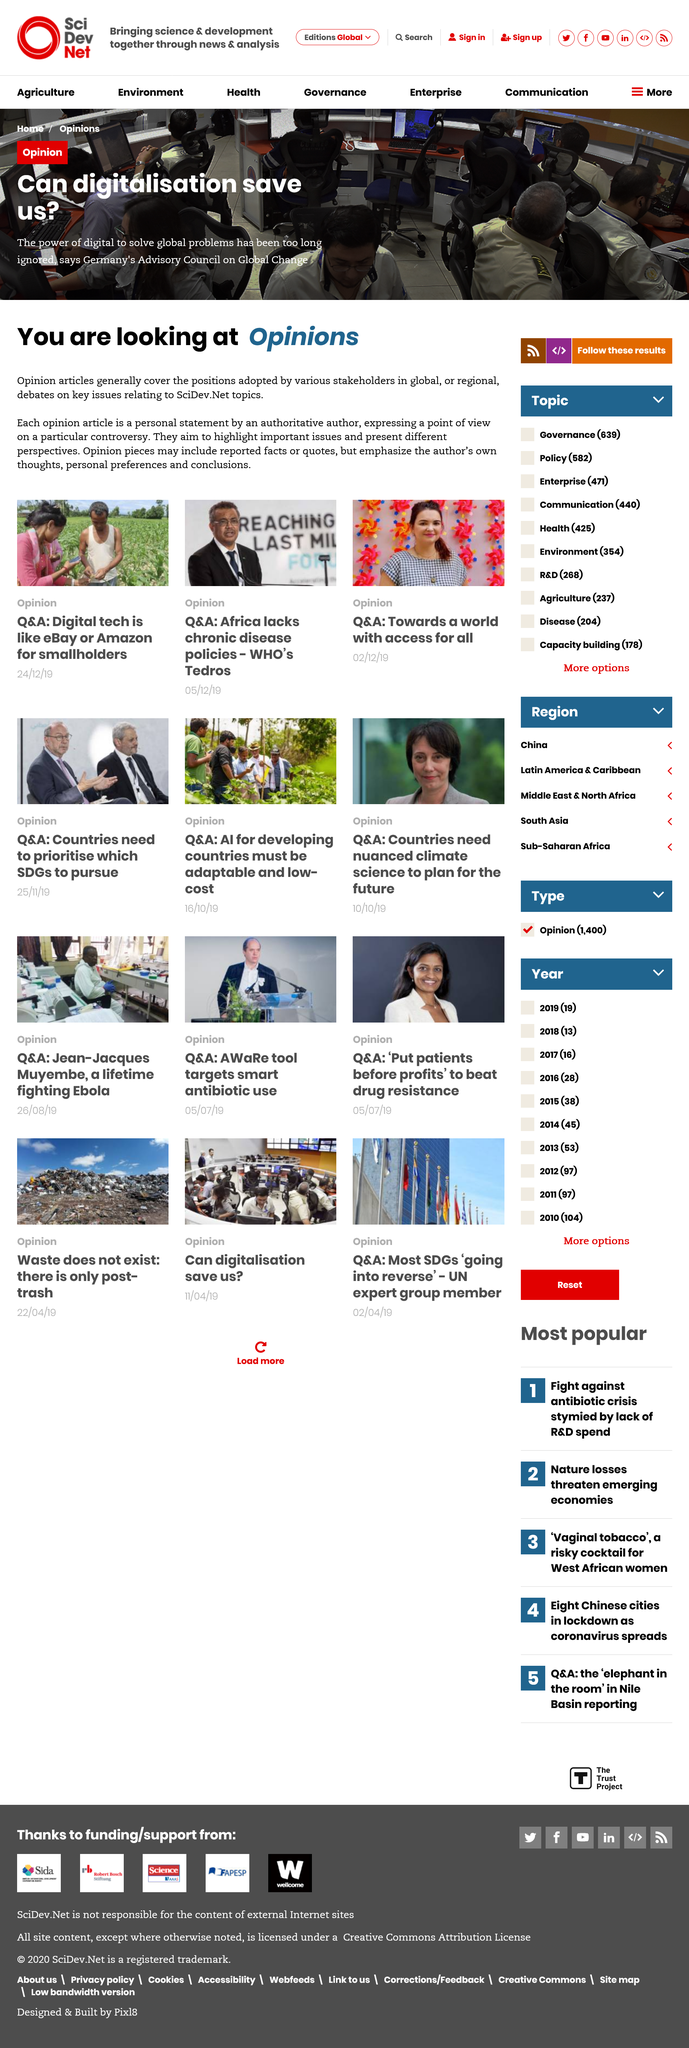Give some essential details in this illustration. The article "Can digitalization save us?" was written by the Advisory Council on Global Change in Germany. The article "Can digitalisation save us?" is an opinion article. 